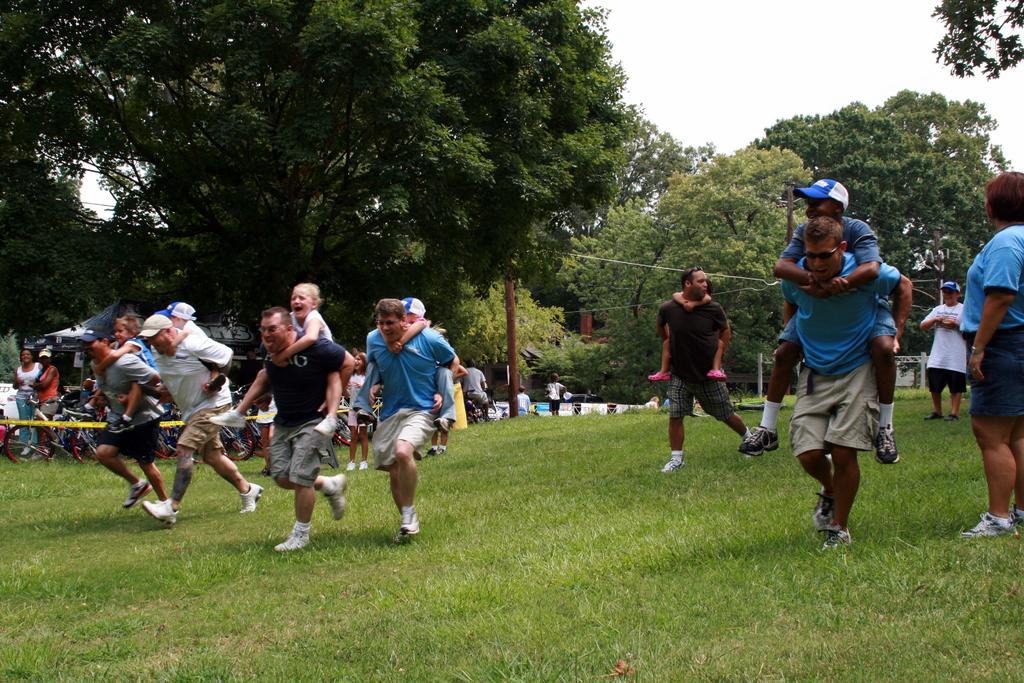Describe this image in one or two sentences. In this image I can see the group of people with different color dresses. I can see few people wearing the caps. To the side of these people I can see the bicycles and few more people. In the background I can see the pole, many trees, and umbrellas and the sky. 